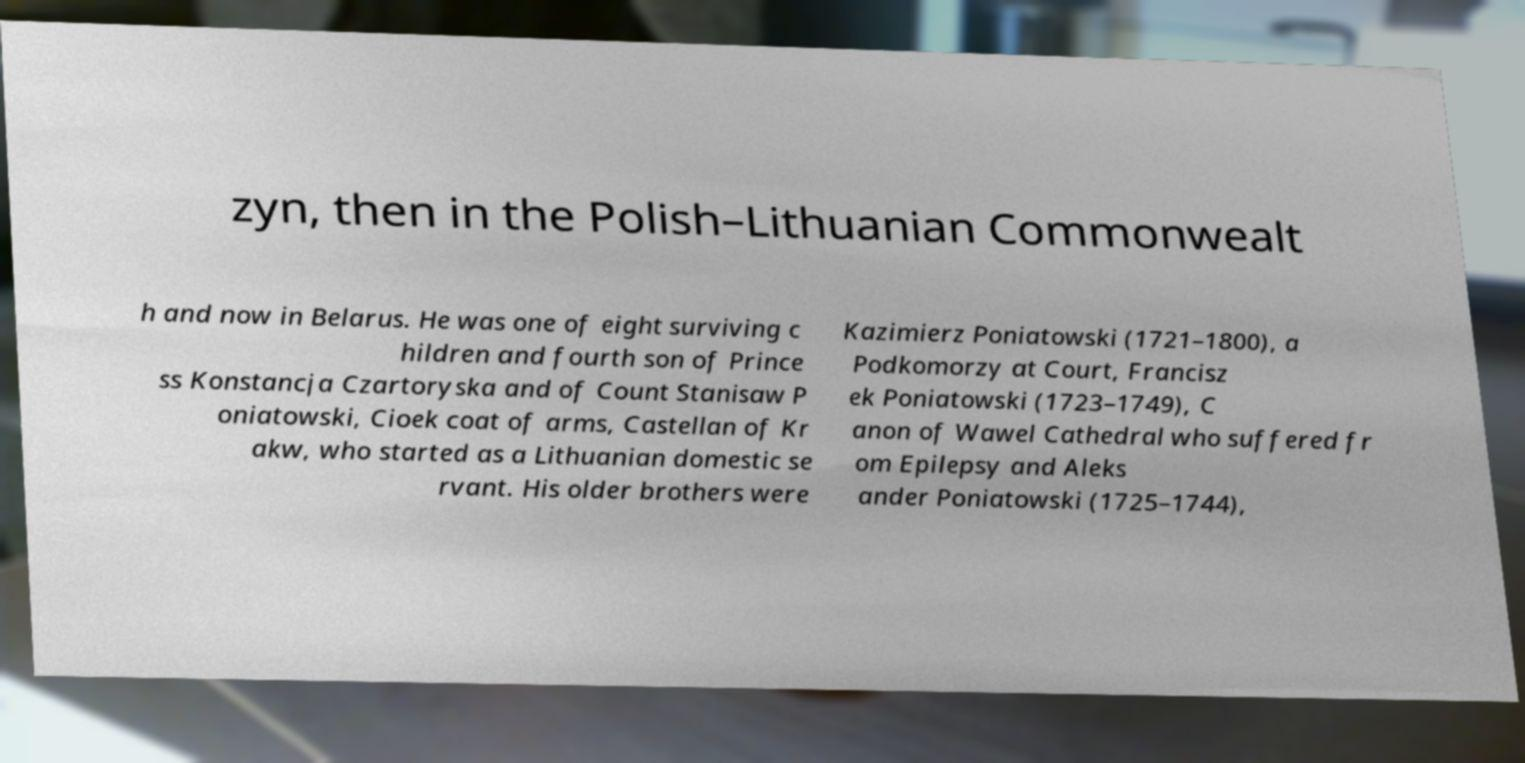Could you extract and type out the text from this image? zyn, then in the Polish–Lithuanian Commonwealt h and now in Belarus. He was one of eight surviving c hildren and fourth son of Prince ss Konstancja Czartoryska and of Count Stanisaw P oniatowski, Cioek coat of arms, Castellan of Kr akw, who started as a Lithuanian domestic se rvant. His older brothers were Kazimierz Poniatowski (1721–1800), a Podkomorzy at Court, Francisz ek Poniatowski (1723–1749), C anon of Wawel Cathedral who suffered fr om Epilepsy and Aleks ander Poniatowski (1725–1744), 